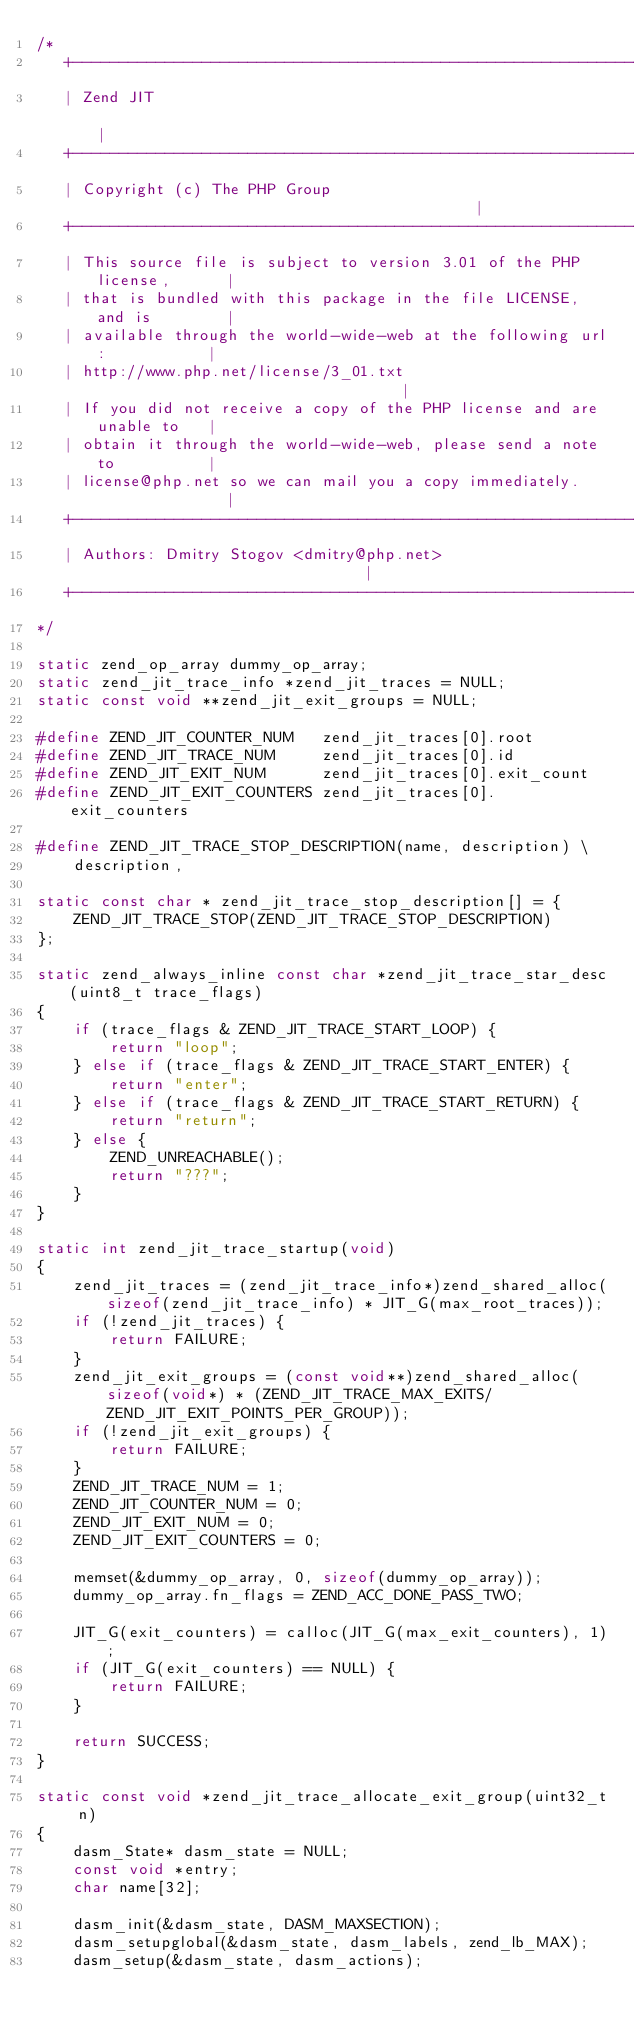<code> <loc_0><loc_0><loc_500><loc_500><_C_>/*
   +----------------------------------------------------------------------+
   | Zend JIT                                                             |
   +----------------------------------------------------------------------+
   | Copyright (c) The PHP Group                                          |
   +----------------------------------------------------------------------+
   | This source file is subject to version 3.01 of the PHP license,      |
   | that is bundled with this package in the file LICENSE, and is        |
   | available through the world-wide-web at the following url:           |
   | http://www.php.net/license/3_01.txt                                  |
   | If you did not receive a copy of the PHP license and are unable to   |
   | obtain it through the world-wide-web, please send a note to          |
   | license@php.net so we can mail you a copy immediately.               |
   +----------------------------------------------------------------------+
   | Authors: Dmitry Stogov <dmitry@php.net>                              |
   +----------------------------------------------------------------------+
*/

static zend_op_array dummy_op_array;
static zend_jit_trace_info *zend_jit_traces = NULL;
static const void **zend_jit_exit_groups = NULL;

#define ZEND_JIT_COUNTER_NUM   zend_jit_traces[0].root
#define ZEND_JIT_TRACE_NUM     zend_jit_traces[0].id
#define ZEND_JIT_EXIT_NUM      zend_jit_traces[0].exit_count
#define ZEND_JIT_EXIT_COUNTERS zend_jit_traces[0].exit_counters

#define ZEND_JIT_TRACE_STOP_DESCRIPTION(name, description) \
	description,

static const char * zend_jit_trace_stop_description[] = {
	ZEND_JIT_TRACE_STOP(ZEND_JIT_TRACE_STOP_DESCRIPTION)
};

static zend_always_inline const char *zend_jit_trace_star_desc(uint8_t trace_flags)
{
	if (trace_flags & ZEND_JIT_TRACE_START_LOOP) {
		return "loop";
	} else if (trace_flags & ZEND_JIT_TRACE_START_ENTER) {
		return "enter";
	} else if (trace_flags & ZEND_JIT_TRACE_START_RETURN) {
		return "return";
	} else {
		ZEND_UNREACHABLE();
		return "???";
	}
}

static int zend_jit_trace_startup(void)
{
	zend_jit_traces = (zend_jit_trace_info*)zend_shared_alloc(sizeof(zend_jit_trace_info) * JIT_G(max_root_traces));
	if (!zend_jit_traces) {
		return FAILURE;
	}
	zend_jit_exit_groups = (const void**)zend_shared_alloc(sizeof(void*) * (ZEND_JIT_TRACE_MAX_EXITS/ZEND_JIT_EXIT_POINTS_PER_GROUP));
	if (!zend_jit_exit_groups) {
		return FAILURE;
	}
	ZEND_JIT_TRACE_NUM = 1;
	ZEND_JIT_COUNTER_NUM = 0;
	ZEND_JIT_EXIT_NUM = 0;
	ZEND_JIT_EXIT_COUNTERS = 0;

	memset(&dummy_op_array, 0, sizeof(dummy_op_array));
	dummy_op_array.fn_flags = ZEND_ACC_DONE_PASS_TWO;

	JIT_G(exit_counters) = calloc(JIT_G(max_exit_counters), 1);
	if (JIT_G(exit_counters) == NULL) {
		return FAILURE;
	}

	return SUCCESS;
}

static const void *zend_jit_trace_allocate_exit_group(uint32_t n)
{
	dasm_State* dasm_state = NULL;
	const void *entry;
	char name[32];

	dasm_init(&dasm_state, DASM_MAXSECTION);
	dasm_setupglobal(&dasm_state, dasm_labels, zend_lb_MAX);
	dasm_setup(&dasm_state, dasm_actions);</code> 